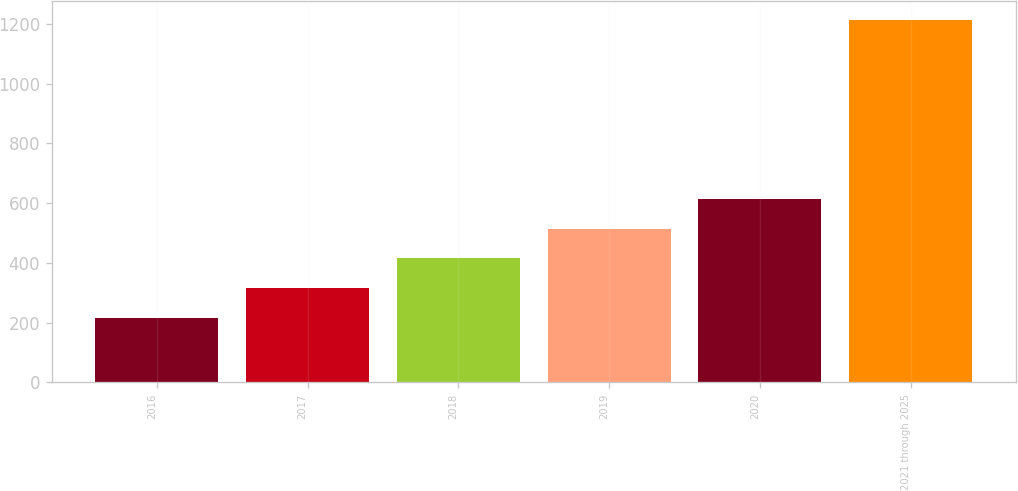Convert chart to OTSL. <chart><loc_0><loc_0><loc_500><loc_500><bar_chart><fcel>2016<fcel>2017<fcel>2018<fcel>2019<fcel>2020<fcel>2021 through 2025<nl><fcel>215<fcel>315<fcel>415<fcel>515<fcel>615<fcel>1215<nl></chart> 